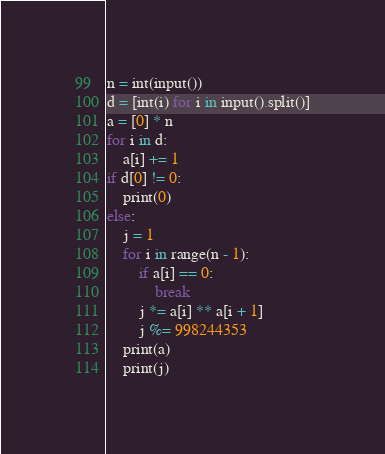Convert code to text. <code><loc_0><loc_0><loc_500><loc_500><_Python_>n = int(input())
d = [int(i) for i in input().split()]
a = [0] * n
for i in d:
    a[i] += 1
if d[0] != 0:
    print(0)
else:
    j = 1
    for i in range(n - 1):
        if a[i] == 0:
            break
        j *= a[i] ** a[i + 1]
        j %= 998244353
    print(a)
    print(j)</code> 